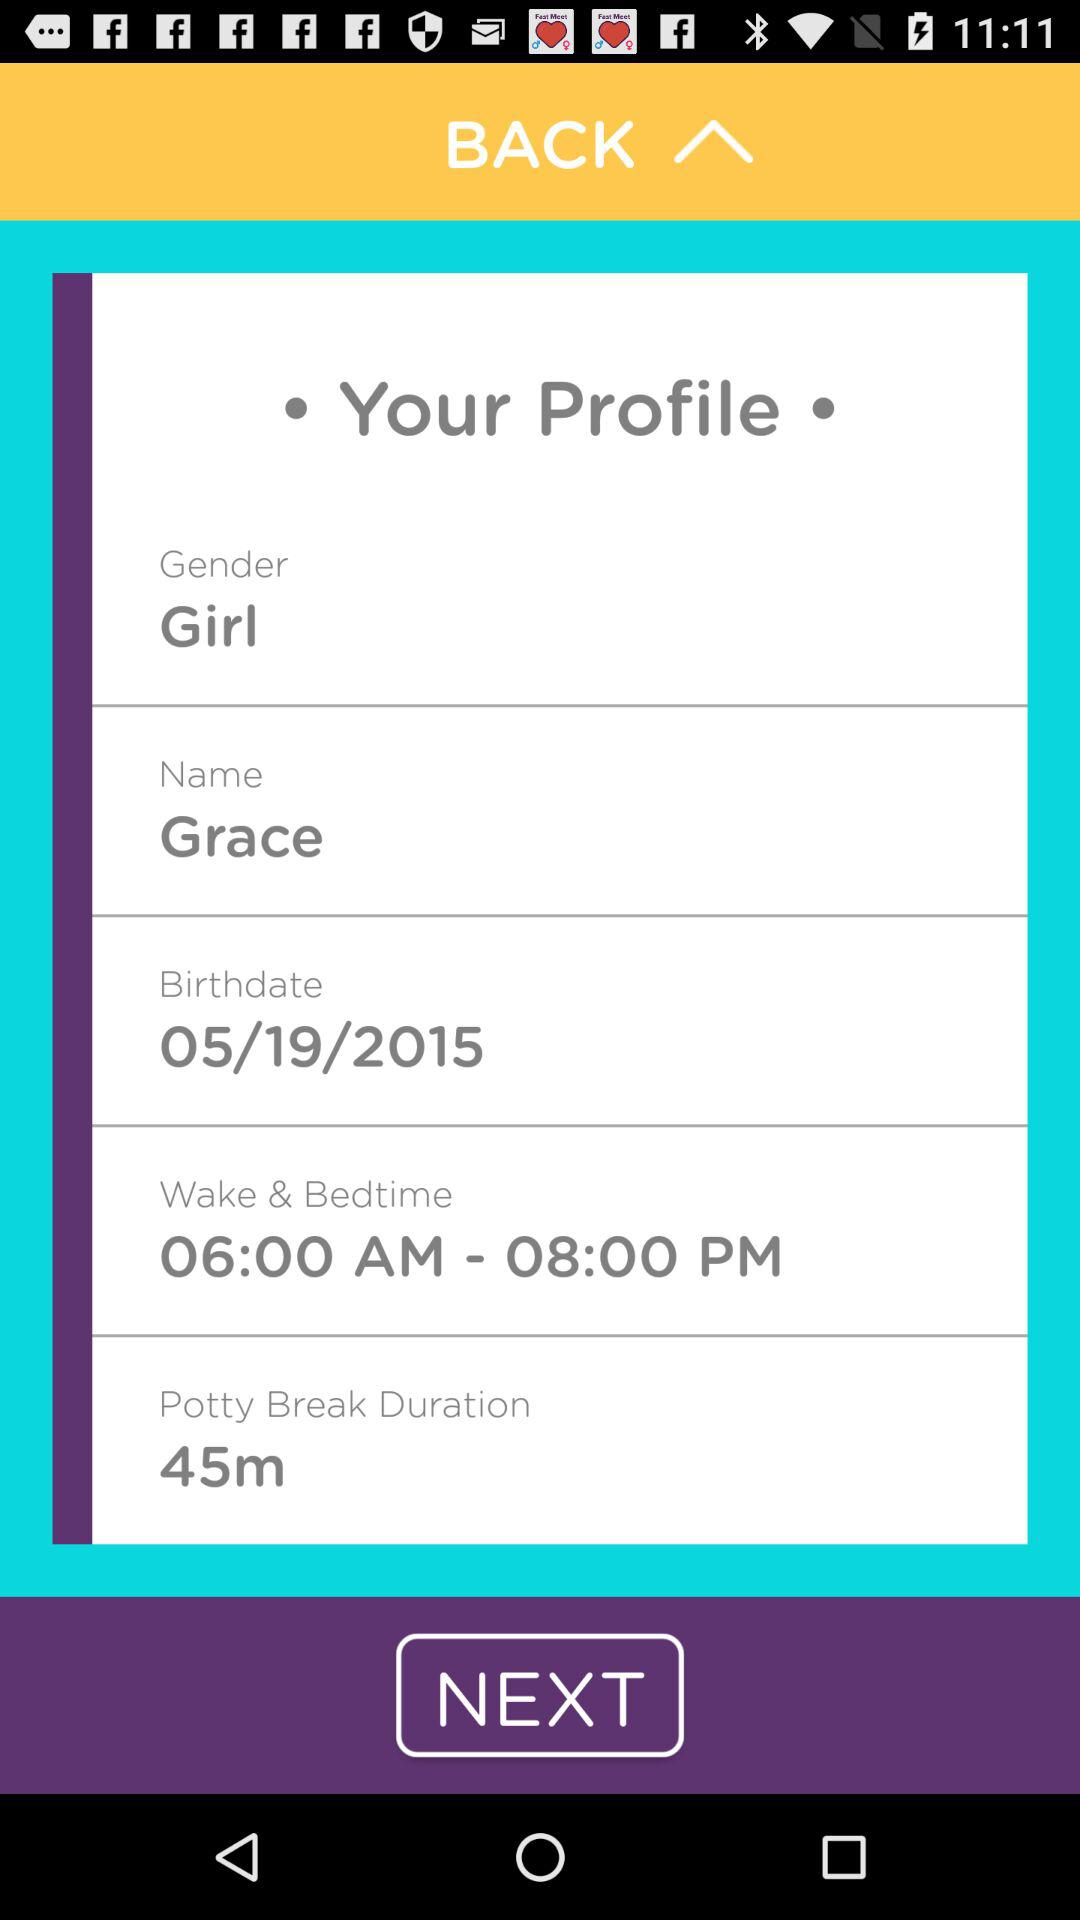What is the name of the user? The name of the user is Grace. 